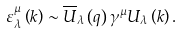Convert formula to latex. <formula><loc_0><loc_0><loc_500><loc_500>\varepsilon ^ { \mu } _ { \lambda } \left ( k \right ) \sim \overline { U } _ { \lambda } \left ( q \right ) \gamma ^ { \mu } U _ { \lambda } \left ( k \right ) .</formula> 